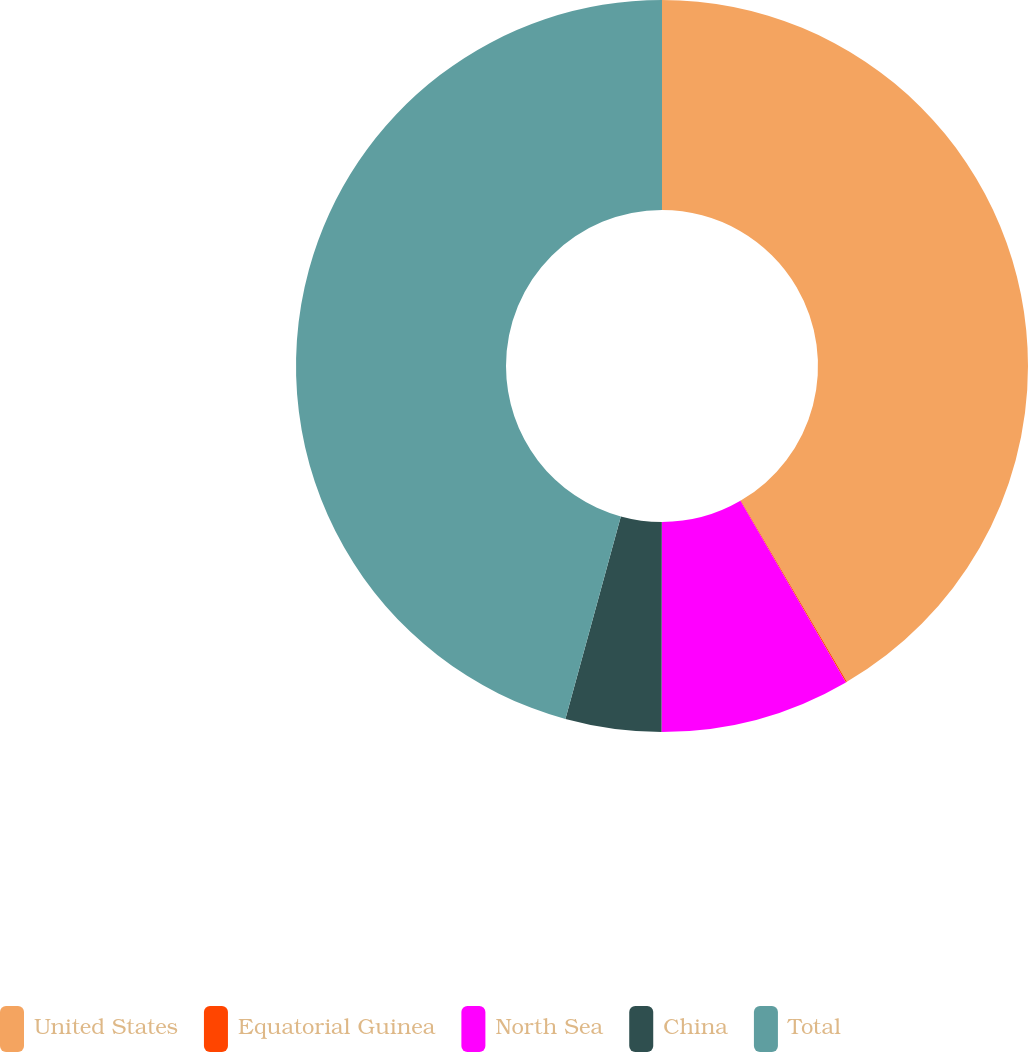<chart> <loc_0><loc_0><loc_500><loc_500><pie_chart><fcel>United States<fcel>Equatorial Guinea<fcel>North Sea<fcel>China<fcel>Total<nl><fcel>41.57%<fcel>0.05%<fcel>8.4%<fcel>4.23%<fcel>45.75%<nl></chart> 